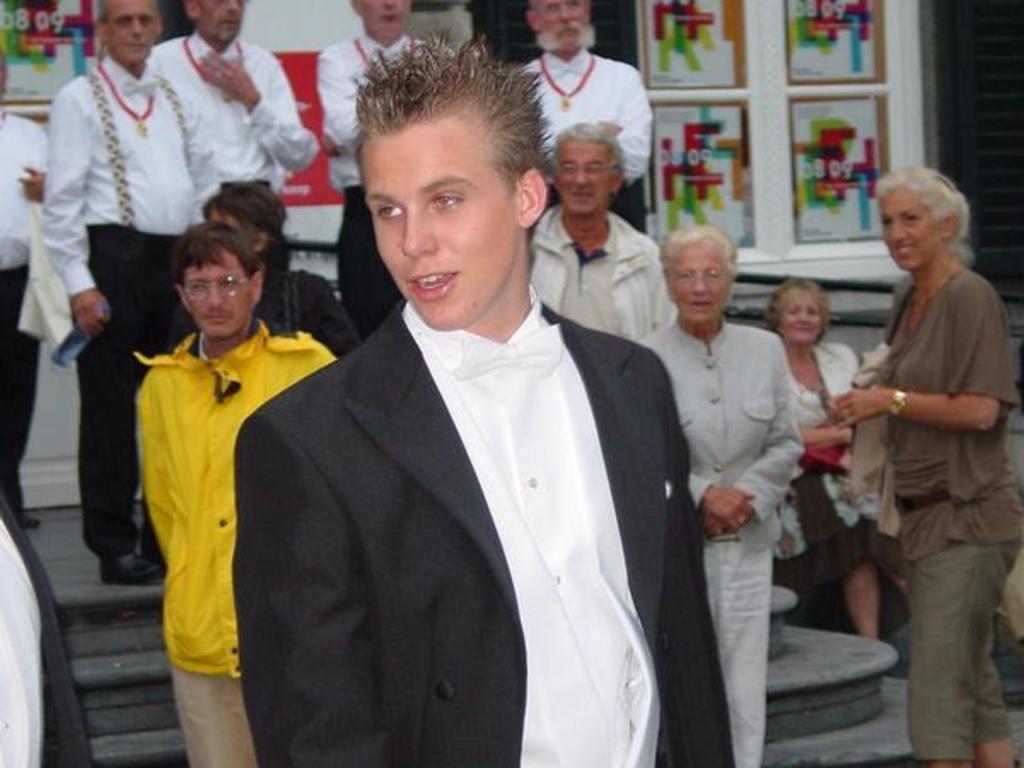Please provide a concise description of this image. There are people and we can see steps. In the background we can see posters on walls. 